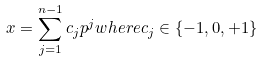Convert formula to latex. <formula><loc_0><loc_0><loc_500><loc_500>x = \sum _ { j = 1 } ^ { n - 1 } c _ { j } p ^ { j } w h e r e c _ { j } \in \{ - 1 , 0 , + 1 \}</formula> 